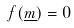<formula> <loc_0><loc_0><loc_500><loc_500>f ( \underline { m } ) = 0</formula> 